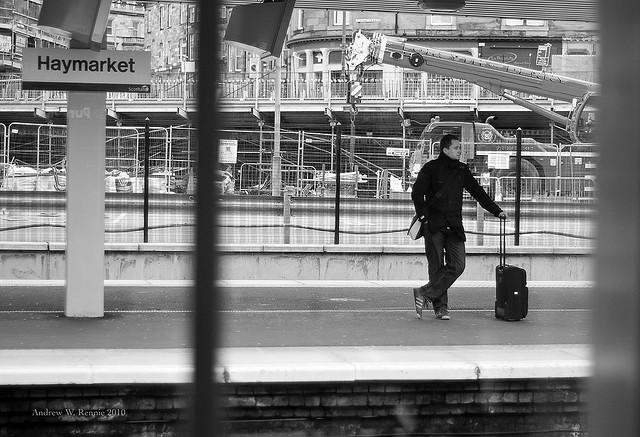What color is the rail?
Write a very short answer. Black. What is the man standing on?
Quick response, please. Platform. What color is the man's jacket?
Short answer required. Black. Is this picture colored?
Quick response, please. No. Is the man waiting for a train?
Write a very short answer. Yes. Is the man looking up or down?
Write a very short answer. Down. How many people are there?
Keep it brief. 1. Who is the in the photo?
Quick response, please. Man. Is anyone wearing pants?
Write a very short answer. Yes. 